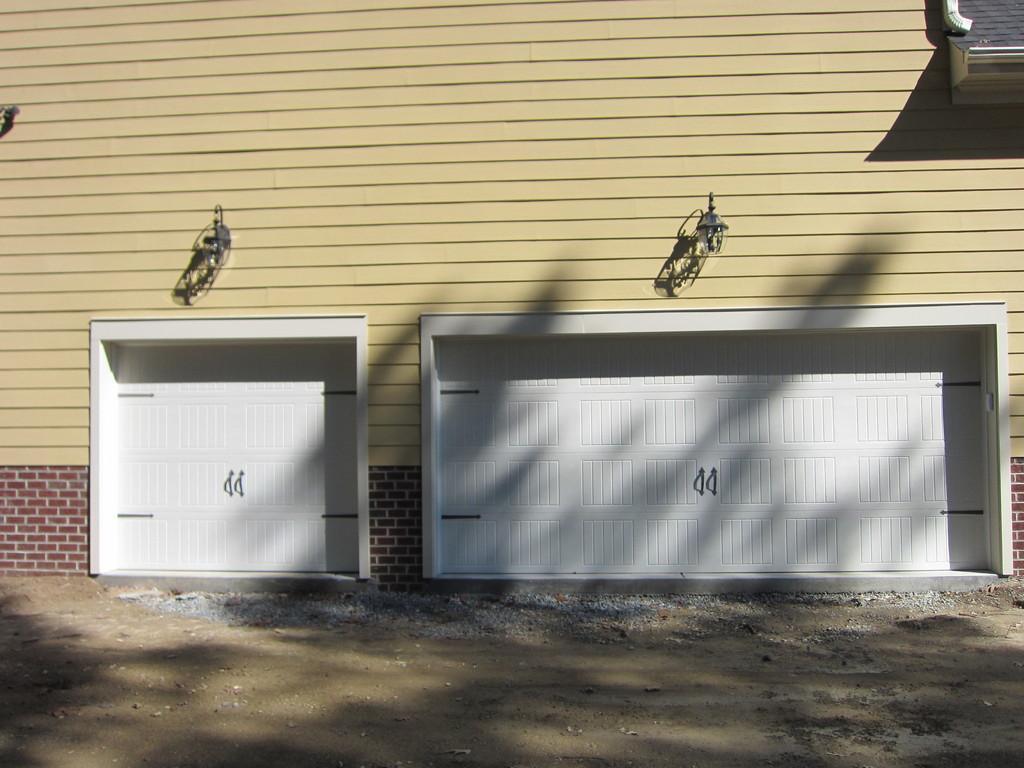Could you give a brief overview of what you see in this image? In this picture there are two white color garage door on the yellow color wall and two hanging lights on the top. In the front bottom side there is a ground. 